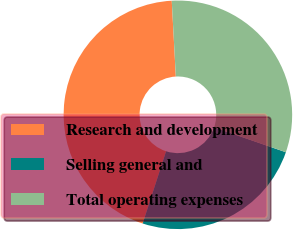Convert chart to OTSL. <chart><loc_0><loc_0><loc_500><loc_500><pie_chart><fcel>Research and development<fcel>Selling general and<fcel>Total operating expenses<nl><fcel>44.16%<fcel>24.68%<fcel>31.17%<nl></chart> 